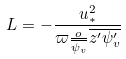<formula> <loc_0><loc_0><loc_500><loc_500>L = - \frac { u _ { * } ^ { 2 } } { \varpi \frac { o } { \overline { \psi _ { v } } } \overline { z ^ { \prime } \psi _ { v } ^ { \prime } } }</formula> 